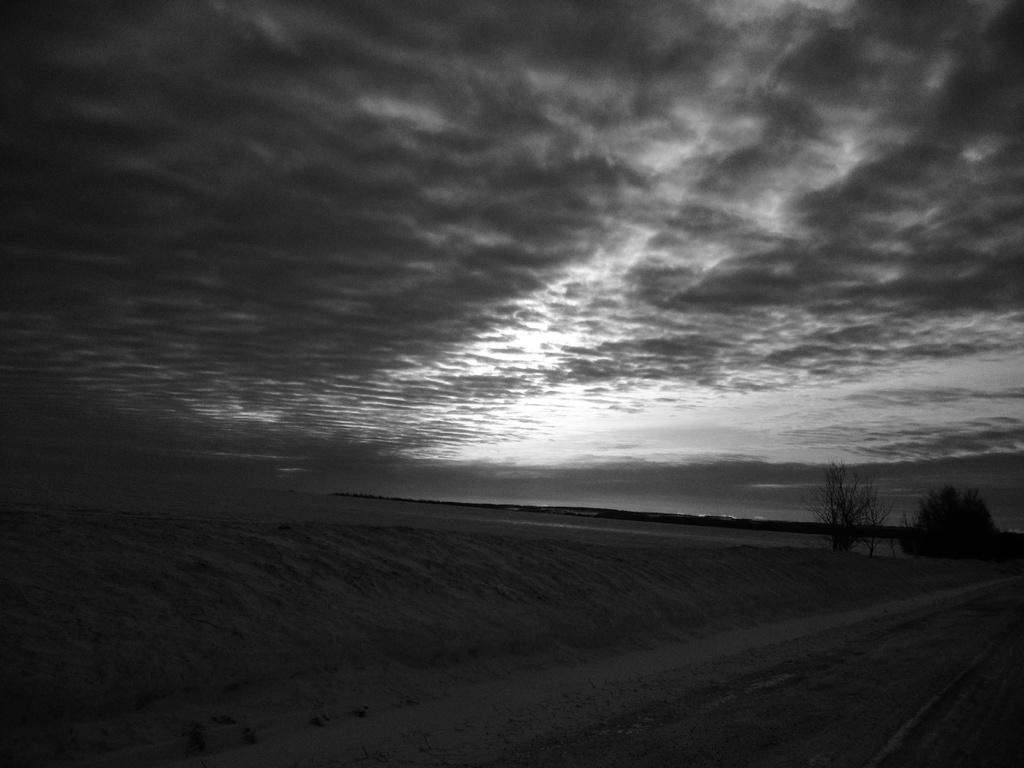What is the color scheme of the image? The image is black and white. What type of terrain can be seen in the image? There is sand visible in the image. What can be seen in the background of the image? There are trees in the background of the image. What is the condition of the sky in the image? The sky is cloudy in the image. How many bushes are present in the image? There are no bushes mentioned or visible in the image. What is the need for the trees in the image? The image does not indicate any specific need for the trees; they are simply part of the background. 